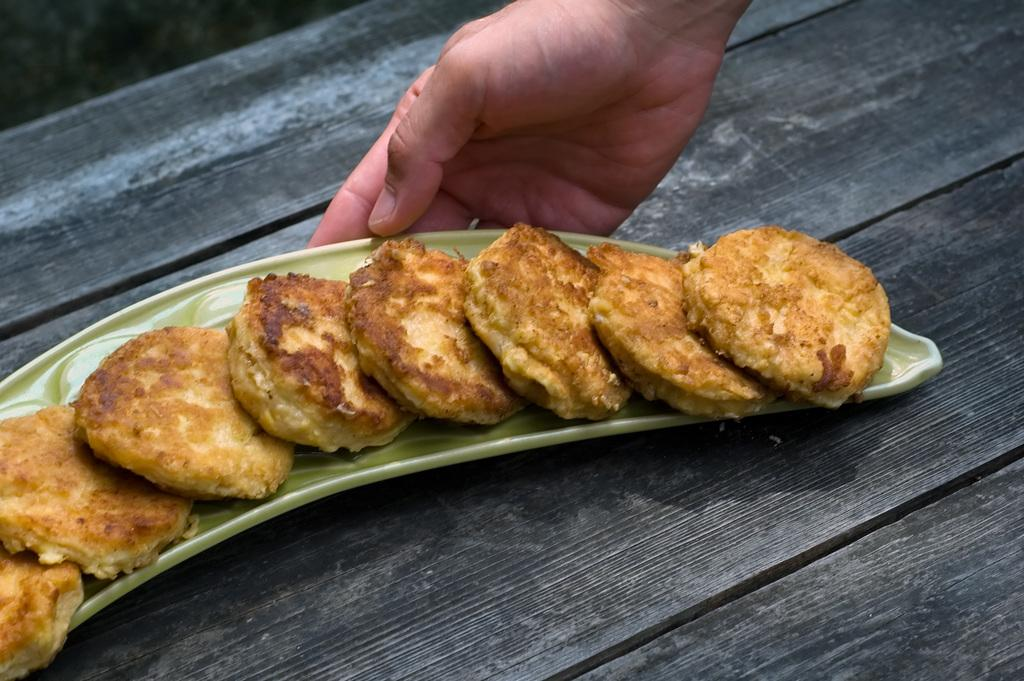What is on the tray in the image? There are food items in a tray in the image. What is the tray placed on? The tray is placed on a wooden table top. Can you describe any part of a person in the image? A person's hand is visible in the image. What is the purpose of the field in the image? There is no field present in the image; it only features food items in a tray, a wooden table top, and a person's hand. 